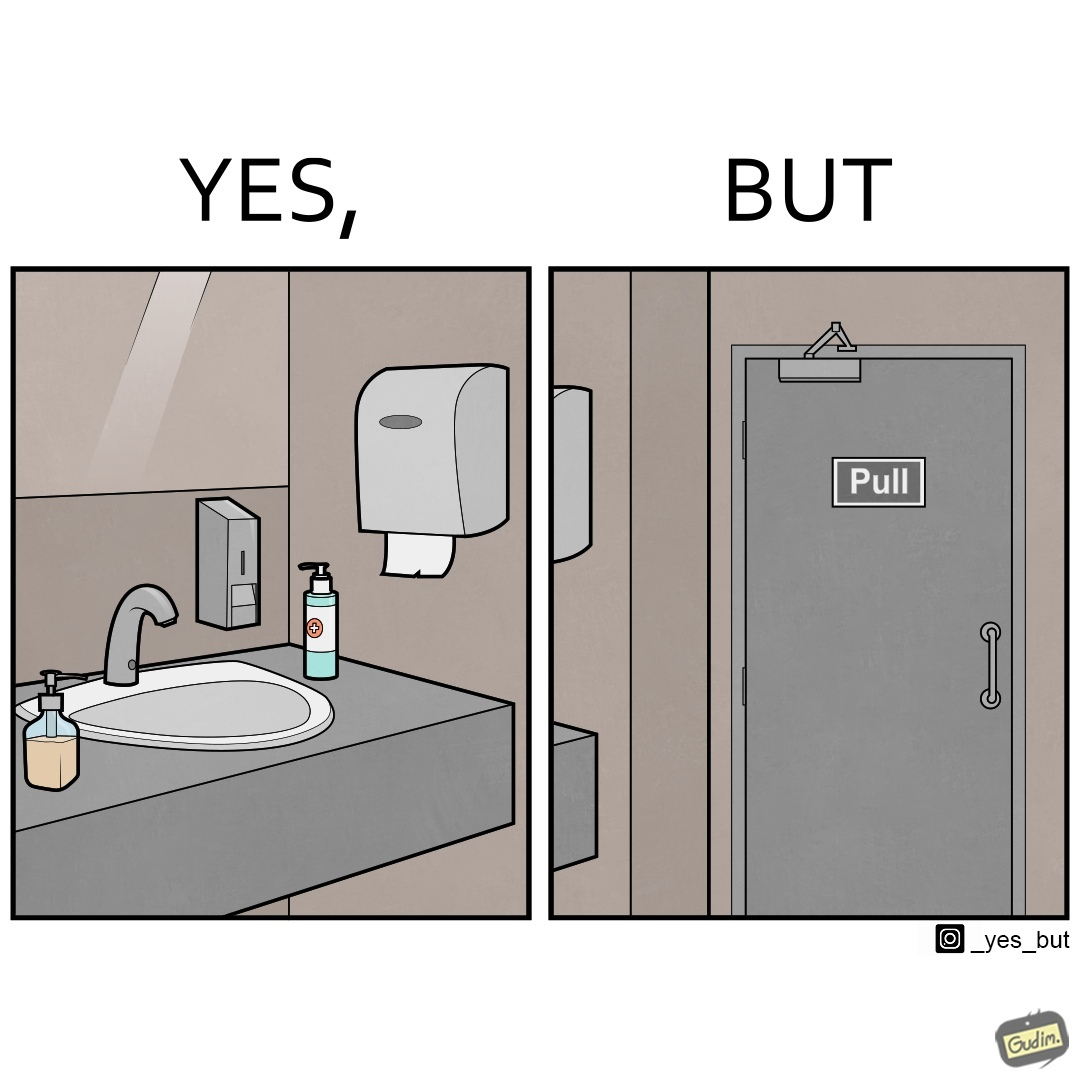Would you classify this image as satirical? Yes, this image is satirical. 